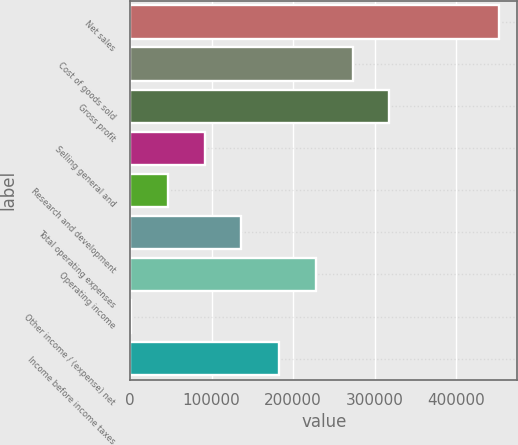<chart> <loc_0><loc_0><loc_500><loc_500><bar_chart><fcel>Net sales<fcel>Cost of goods sold<fcel>Gross profit<fcel>Selling general and<fcel>Research and development<fcel>Total operating expenses<fcel>Operating income<fcel>Other income / (expense) net<fcel>Income before income taxes<nl><fcel>452437<fcel>272960<fcel>318089<fcel>91402.6<fcel>46273.3<fcel>136532<fcel>227830<fcel>1144<fcel>182701<nl></chart> 